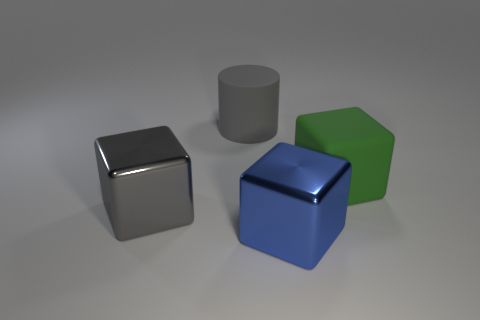Subtract all large green matte cubes. How many cubes are left? 2 Add 3 gray metal cubes. How many objects exist? 7 Subtract all gray cubes. How many cubes are left? 2 Subtract all cubes. How many objects are left? 1 Subtract 1 cylinders. How many cylinders are left? 0 Subtract all green cylinders. Subtract all green cubes. How many cylinders are left? 1 Add 1 large green matte blocks. How many large green matte blocks are left? 2 Add 1 gray cylinders. How many gray cylinders exist? 2 Subtract 0 brown cylinders. How many objects are left? 4 Subtract all large red metallic cylinders. Subtract all gray blocks. How many objects are left? 3 